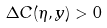Convert formula to latex. <formula><loc_0><loc_0><loc_500><loc_500>\Delta C ( \eta , y ) > 0</formula> 